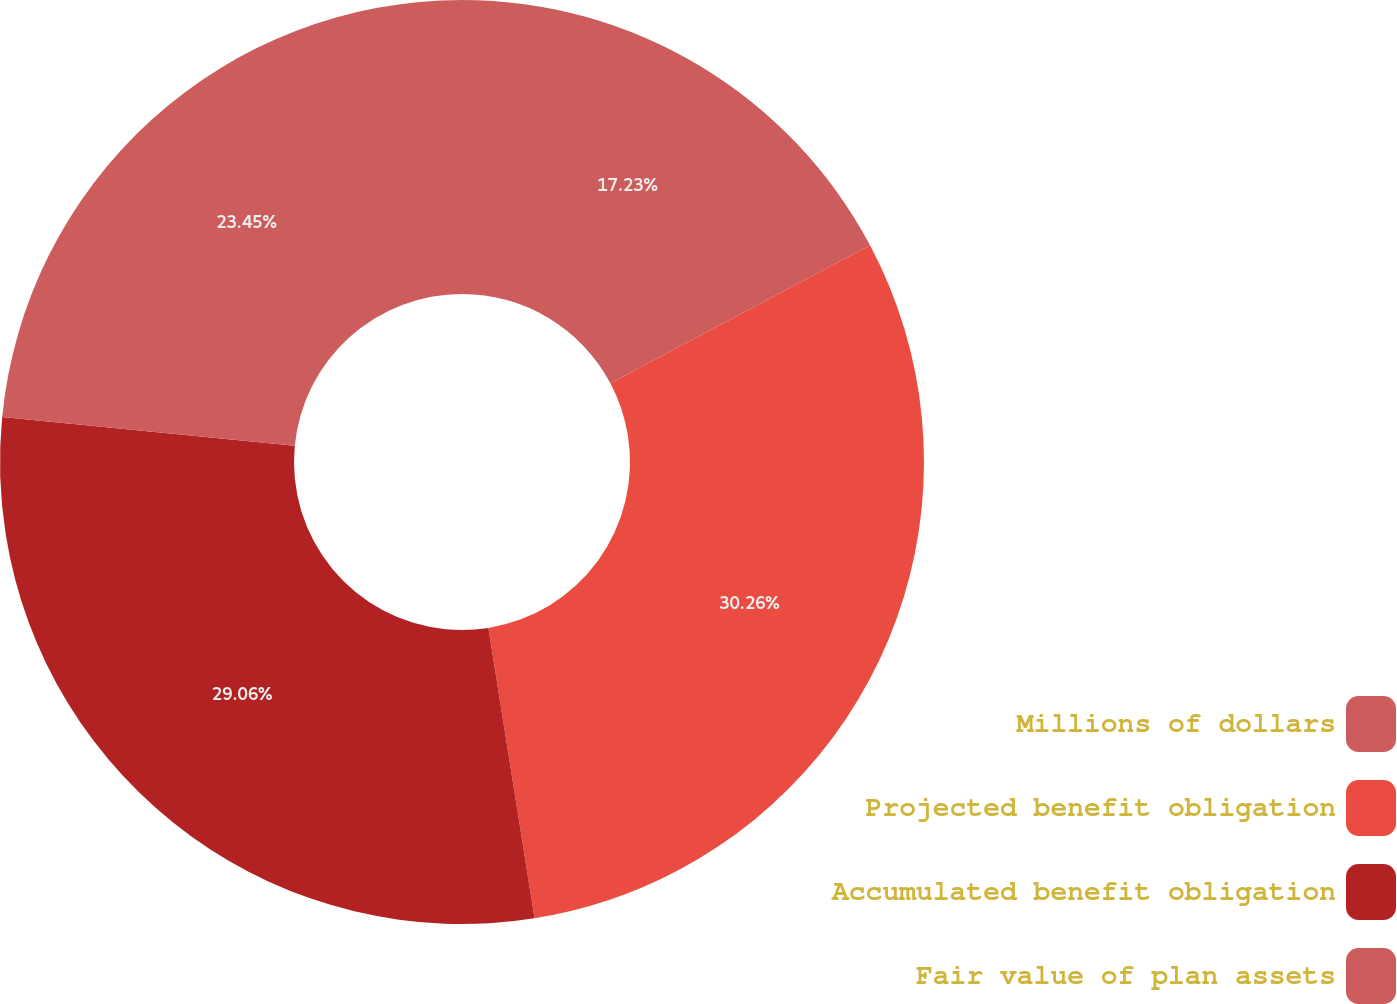<chart> <loc_0><loc_0><loc_500><loc_500><pie_chart><fcel>Millions of dollars<fcel>Projected benefit obligation<fcel>Accumulated benefit obligation<fcel>Fair value of plan assets<nl><fcel>17.23%<fcel>30.26%<fcel>29.06%<fcel>23.45%<nl></chart> 